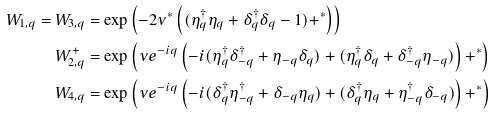Convert formula to latex. <formula><loc_0><loc_0><loc_500><loc_500>W _ { 1 , q } = W _ { 3 , q } & = \exp \left ( - 2 \nu ^ { * } \left ( ( \eta _ { q } ^ { \dagger } \eta _ { q } + \delta _ { q } ^ { \dagger } \delta _ { q } - 1 ) + ^ { * } \right ) \right ) \\ W ^ { + } _ { 2 , q } & = \exp \left ( \nu e ^ { - i q } \left ( - i ( \eta _ { q } ^ { \dagger } \delta _ { - q } ^ { \dagger } + \eta _ { - q } \delta _ { q } ) + ( \eta _ { q } ^ { \dagger } \delta _ { q } + \delta _ { - q } ^ { \dagger } \eta _ { - q } ) \right ) + ^ { * } \right ) \\ W _ { 4 , q } & = \exp \left ( \nu e ^ { - i q } \left ( - i ( \delta _ { q } ^ { \dagger } \eta _ { - q } ^ { \dagger } + \delta _ { - q } \eta _ { q } ) + ( \delta _ { q } ^ { \dagger } \eta _ { q } + \eta _ { - q } ^ { \dagger } \delta _ { - q } ) \right ) + ^ { * } \right )</formula> 